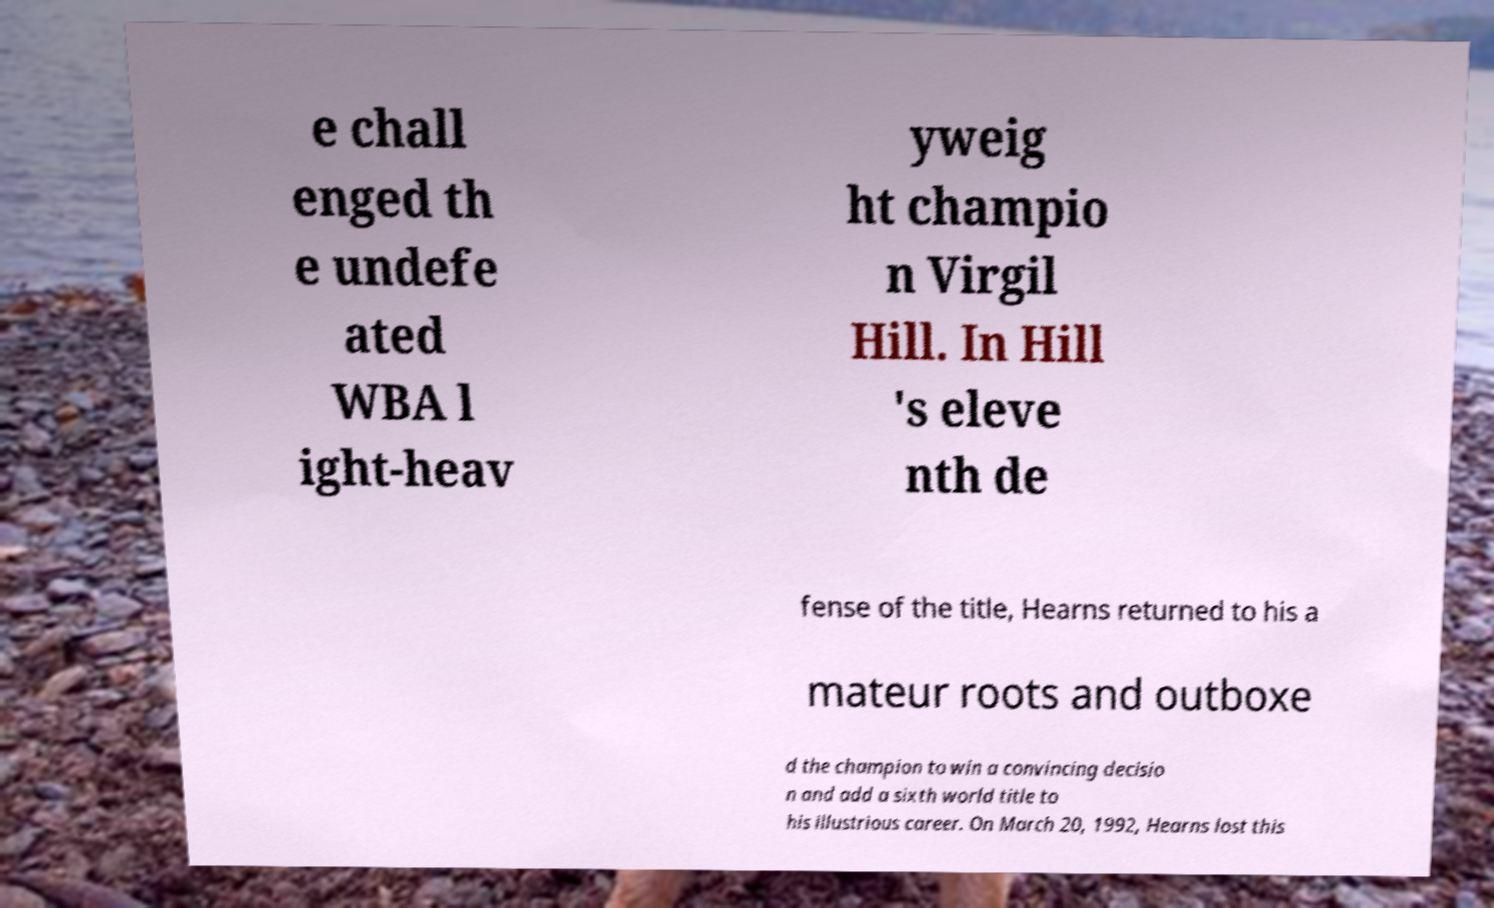Please identify and transcribe the text found in this image. e chall enged th e undefe ated WBA l ight-heav yweig ht champio n Virgil Hill. In Hill 's eleve nth de fense of the title, Hearns returned to his a mateur roots and outboxe d the champion to win a convincing decisio n and add a sixth world title to his illustrious career. On March 20, 1992, Hearns lost this 